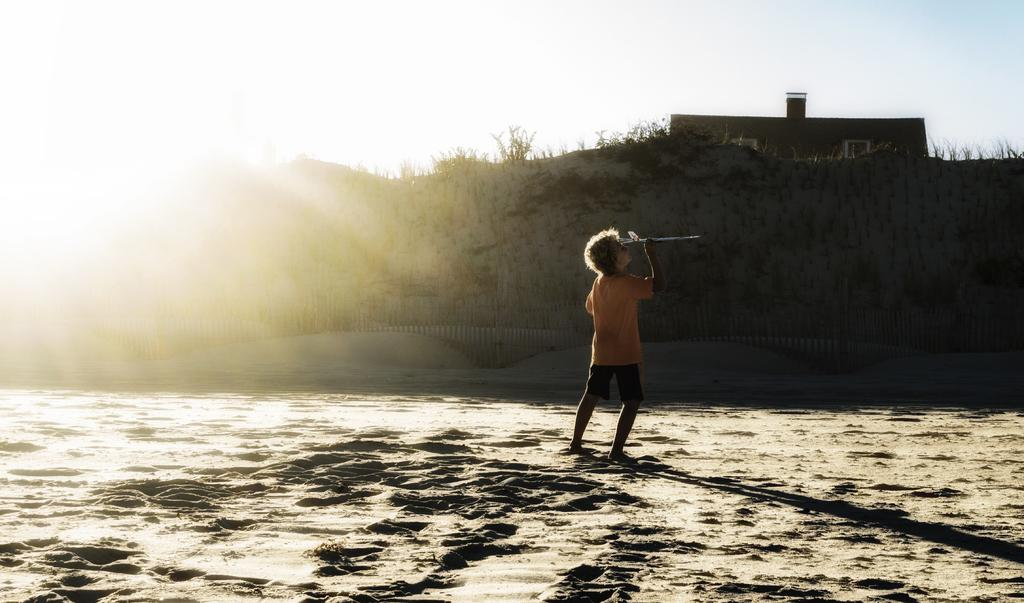What is the main subject of the image? The main subject of the image is a boy. What is the boy doing in the image? The boy is standing in the image. What is the boy holding in his hand? The boy is holding an object in his hand. What can be seen in the background of the image? In the background of the image, there is sky, the sun, a house, trees, and other unspecified objects. What type of profit can be seen in the image? There is no mention of profit in the image; it features a boy standing and holding an object. Can you tell me how many jellyfish are swimming in the background of the image? There are no jellyfish present in the image; the background features a house, trees, and other unspecified objects. 